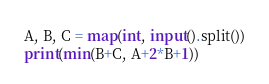<code> <loc_0><loc_0><loc_500><loc_500><_Python_>A, B, C = map(int, input().split())
print(min(B+C, A+2*B+1))</code> 